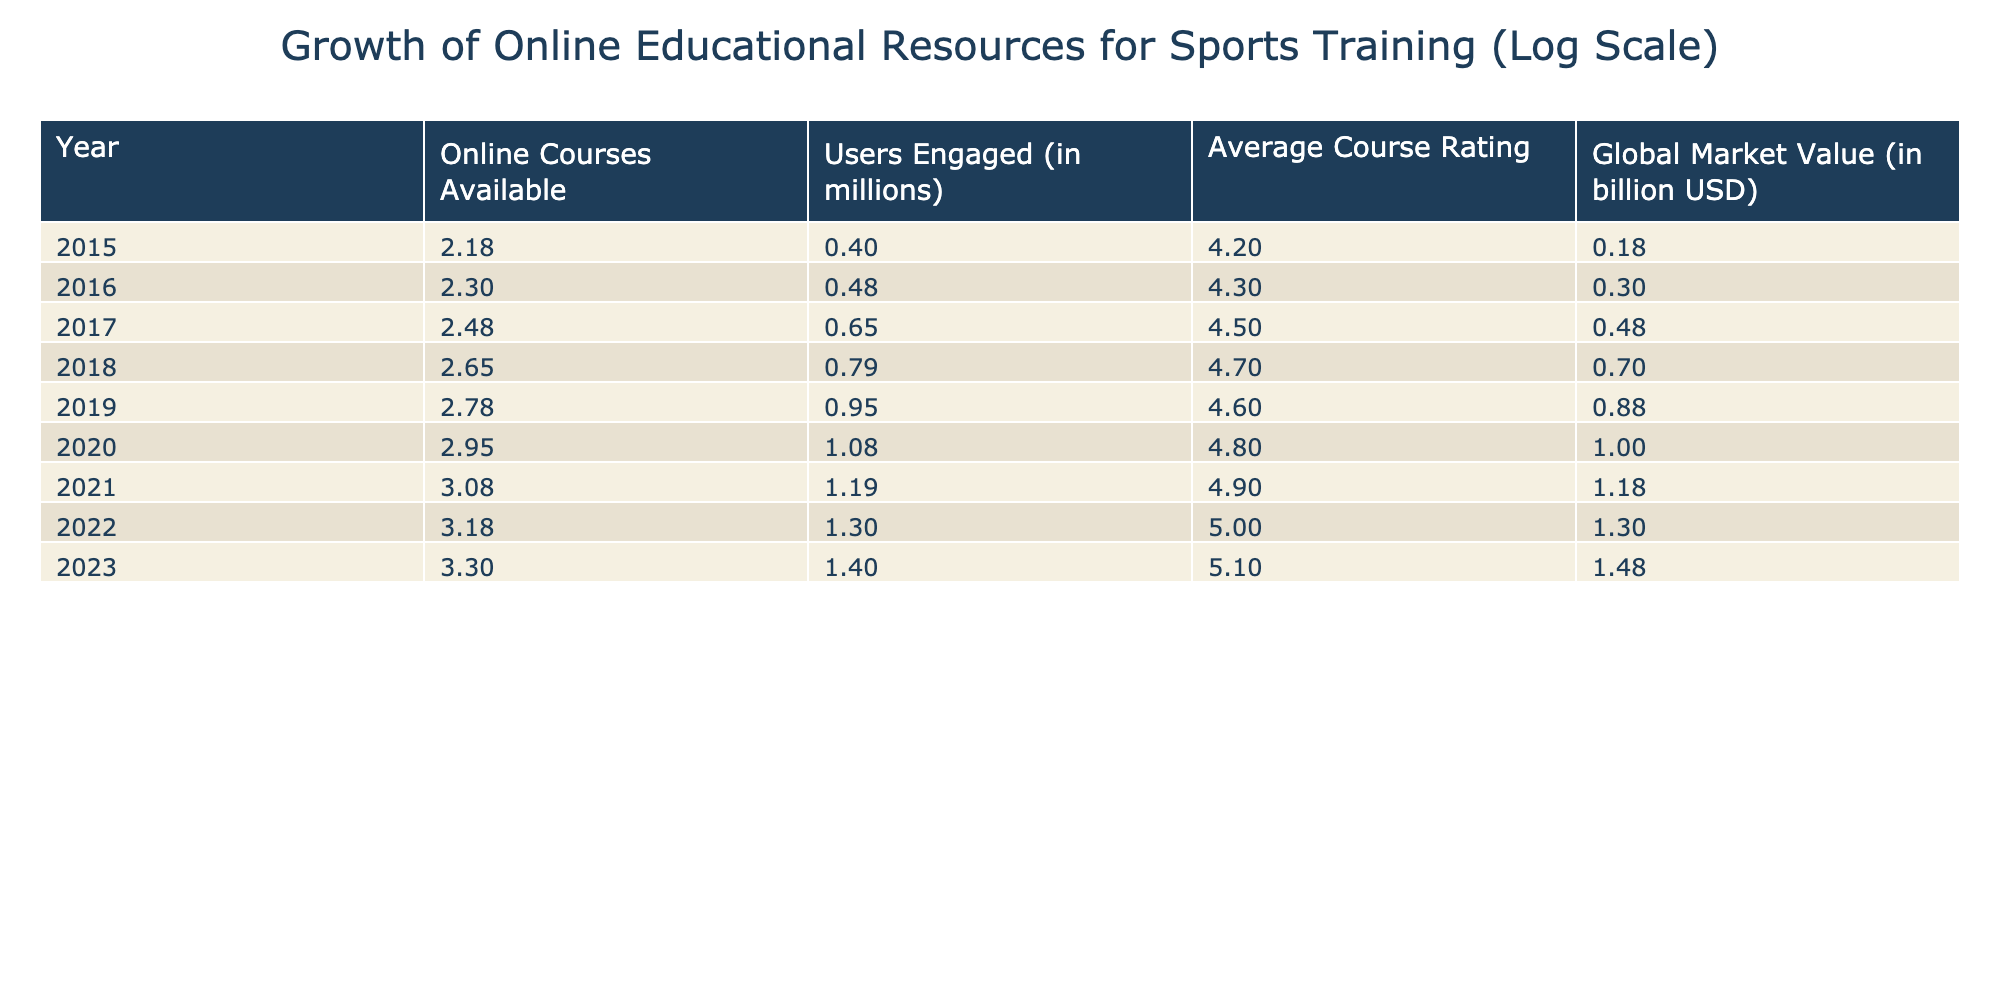What year had the highest number of online courses available? By looking at the "Online Courses Available" column, I can see that the year 2023 has the highest value of 2000.
Answer: 2023 What was the average course rating in 2020? The "Average Course Rating" for the year 2020 is 4.8, which can be found directly in the table.
Answer: 4.8 What is the total number of users engaged (in millions) from 2015 to 2023? To find the total, I sum the number of users engaged for each year: 2.5 + 3.0 + 4.5 + 6.2 + 9.0 + 12.0 + 15.5 + 20.0 + 25.0 = 97.7.
Answer: 97.7 Did the global market value increase every year from 2015 to 2023? The global market values for each year show an increasing trend: 1.5, 2.0, 3.0, 5.0, 7.5, 10.0, 15.0, 20.0, and 30.0. Since there are no values that are lower than the previous year, the answer is yes.
Answer: Yes What is the average number of users engaged per course available in 2022? To calculate this, divide the number of users (20.0 million) by the number of courses available (1500). The result is approximately 0.0133 million users per course, or about 13.3 users per course.
Answer: 13.3 million users per course 